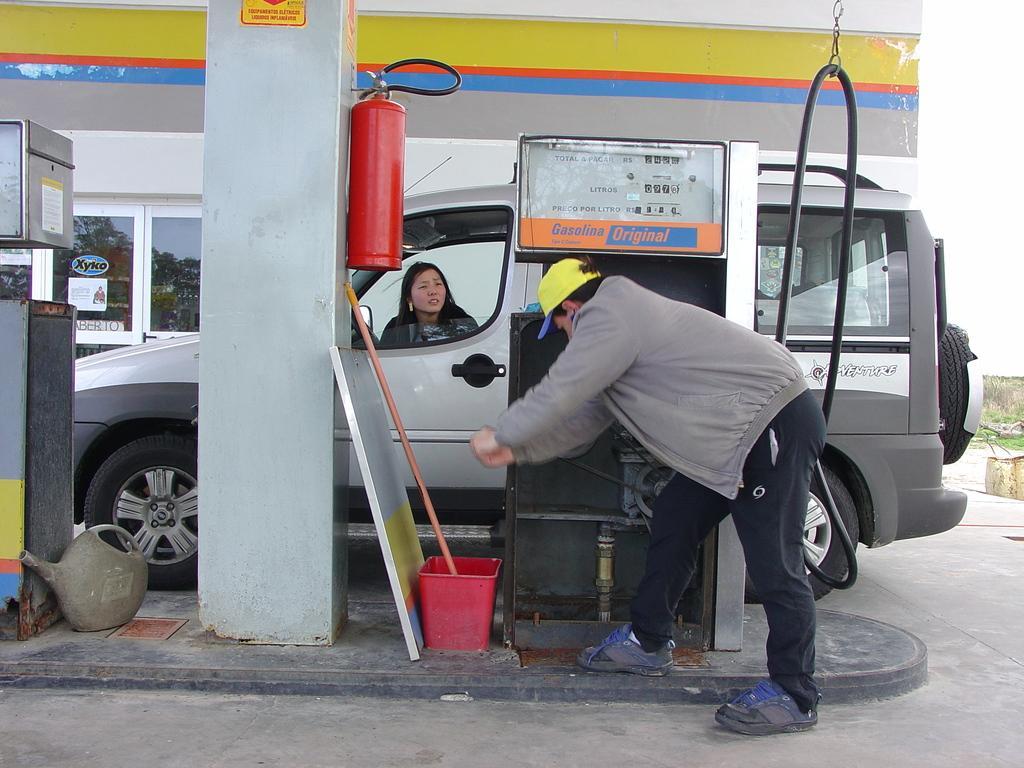In one or two sentences, can you explain what this image depicts? In this picture we can see a Man a Woman and a car in the petrol bunk. 